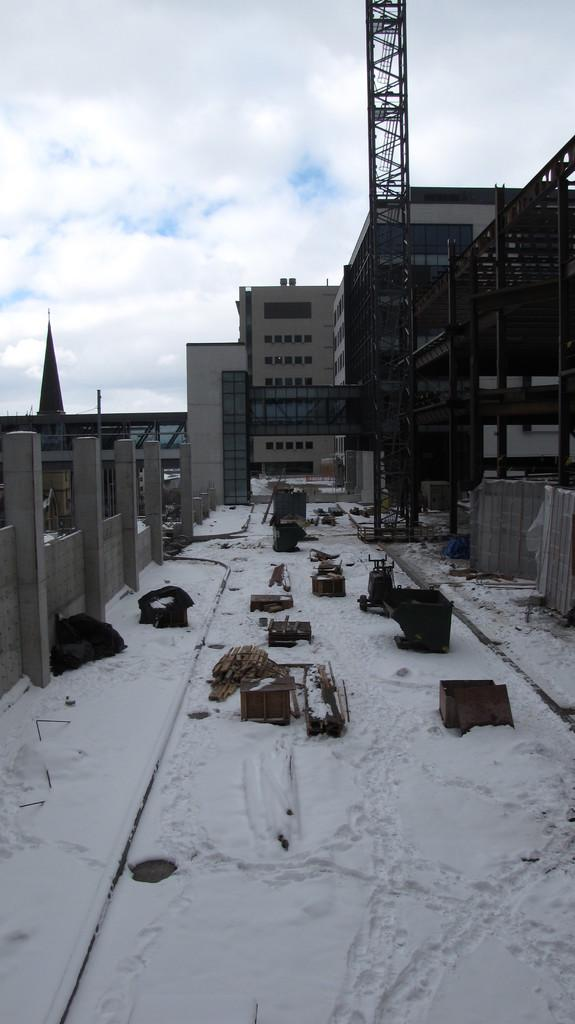What type of structures can be seen in the image? There are buildings in the image. What is the closest object to the viewer in the image? There is a tower in the foreground of the image. What else can be seen in the foreground of the image besides the tower? There are objects in the foreground of the image. What is visible at the top of the image? The sky is visible at the top of the image. What can be observed in the sky? There are clouds in the sky. What is present at the bottom of the image? Snow is present at the bottom of the image. Can you tell me how many bees are buzzing around the tower in the image? There are no bees present in the image; the focus is on the tower, buildings, and the sky. What type of weather condition is depicted by the fog in the image? There is no fog present in the image; it only mentions clouds in the sky. 